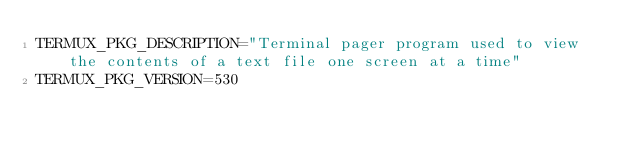Convert code to text. <code><loc_0><loc_0><loc_500><loc_500><_Bash_>TERMUX_PKG_DESCRIPTION="Terminal pager program used to view the contents of a text file one screen at a time"
TERMUX_PKG_VERSION=530</code> 